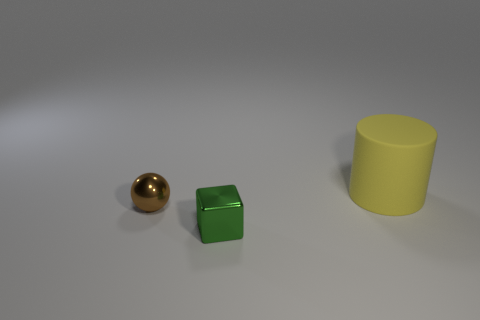There is a small object that is behind the shiny thing that is in front of the small brown metallic sphere; what is its color?
Your answer should be very brief. Brown. Is the green shiny cube the same size as the cylinder?
Provide a short and direct response. No. There is a thing that is in front of the big yellow thing and right of the tiny brown metal object; what color is it?
Make the answer very short. Green. What size is the brown sphere?
Your response must be concise. Small. There is a shiny object right of the tiny shiny ball; is it the same color as the tiny sphere?
Provide a short and direct response. No. Is the number of large yellow things that are in front of the block greater than the number of brown spheres left of the small brown metal object?
Offer a terse response. No. Are there more small brown metallic balls than large yellow rubber balls?
Offer a terse response. Yes. What is the size of the thing that is on the right side of the tiny sphere and behind the tiny green shiny cube?
Keep it short and to the point. Large. What shape is the green object?
Your response must be concise. Cube. Is there any other thing that is the same size as the brown metallic thing?
Provide a succinct answer. Yes. 